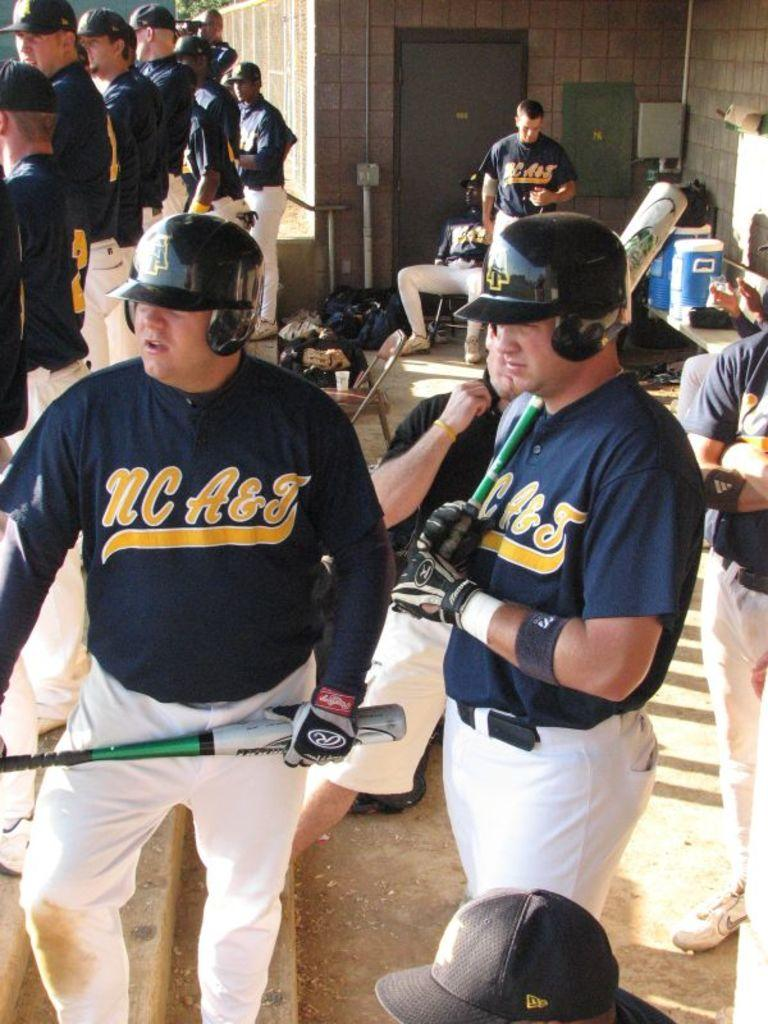<image>
Describe the image concisely. the letter nc is on the jersey of a baseball player 